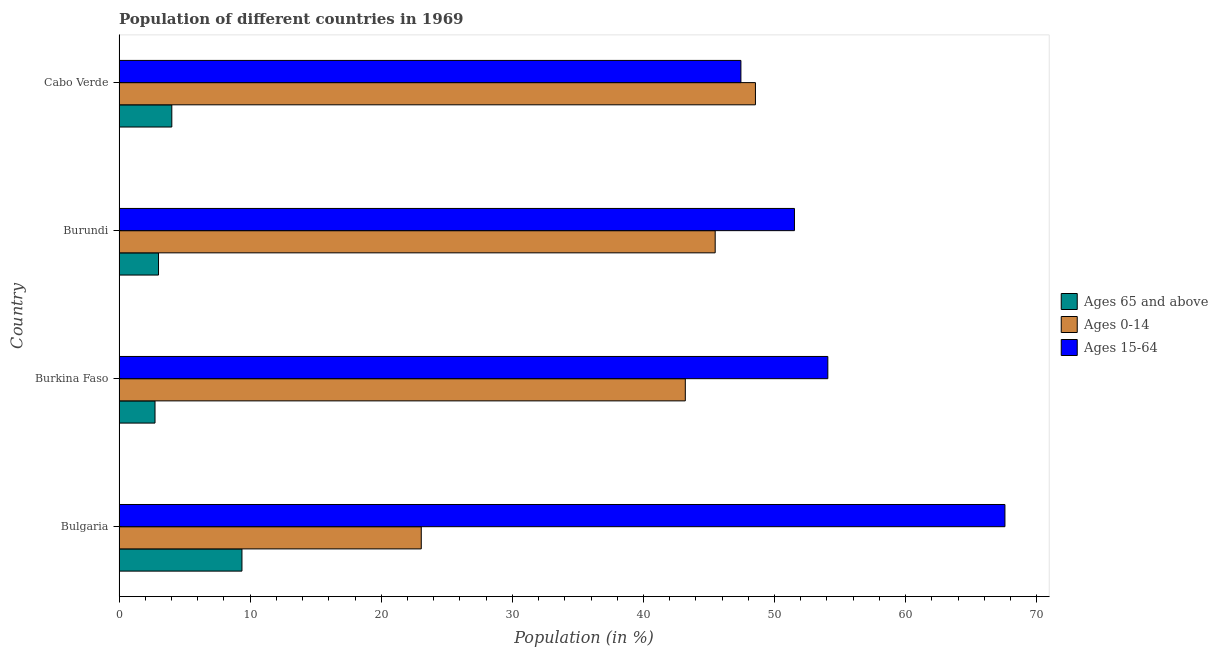How many groups of bars are there?
Give a very brief answer. 4. Are the number of bars per tick equal to the number of legend labels?
Your response must be concise. Yes. Are the number of bars on each tick of the Y-axis equal?
Provide a succinct answer. Yes. How many bars are there on the 3rd tick from the top?
Ensure brevity in your answer.  3. What is the label of the 1st group of bars from the top?
Offer a terse response. Cabo Verde. What is the percentage of population within the age-group of 65 and above in Bulgaria?
Your response must be concise. 9.37. Across all countries, what is the maximum percentage of population within the age-group 15-64?
Your answer should be compact. 67.57. Across all countries, what is the minimum percentage of population within the age-group 15-64?
Your response must be concise. 47.43. In which country was the percentage of population within the age-group 15-64 maximum?
Make the answer very short. Bulgaria. In which country was the percentage of population within the age-group 15-64 minimum?
Offer a terse response. Cabo Verde. What is the total percentage of population within the age-group 15-64 in the graph?
Give a very brief answer. 220.59. What is the difference between the percentage of population within the age-group 0-14 in Burkina Faso and that in Cabo Verde?
Offer a terse response. -5.35. What is the difference between the percentage of population within the age-group of 65 and above in Burundi and the percentage of population within the age-group 0-14 in Burkina Faso?
Ensure brevity in your answer.  -40.18. What is the average percentage of population within the age-group 0-14 per country?
Provide a succinct answer. 40.06. What is the difference between the percentage of population within the age-group of 65 and above and percentage of population within the age-group 0-14 in Burundi?
Your answer should be very brief. -42.46. In how many countries, is the percentage of population within the age-group 0-14 greater than 26 %?
Offer a terse response. 3. What is the difference between the highest and the second highest percentage of population within the age-group of 65 and above?
Make the answer very short. 5.35. What is the difference between the highest and the lowest percentage of population within the age-group 15-64?
Make the answer very short. 20.14. In how many countries, is the percentage of population within the age-group 0-14 greater than the average percentage of population within the age-group 0-14 taken over all countries?
Provide a short and direct response. 3. Is the sum of the percentage of population within the age-group 0-14 in Bulgaria and Burundi greater than the maximum percentage of population within the age-group of 65 and above across all countries?
Provide a short and direct response. Yes. What does the 1st bar from the top in Bulgaria represents?
Keep it short and to the point. Ages 15-64. What does the 2nd bar from the bottom in Burundi represents?
Your response must be concise. Ages 0-14. Is it the case that in every country, the sum of the percentage of population within the age-group of 65 and above and percentage of population within the age-group 0-14 is greater than the percentage of population within the age-group 15-64?
Give a very brief answer. No. How many bars are there?
Keep it short and to the point. 12. Are all the bars in the graph horizontal?
Your response must be concise. Yes. How many countries are there in the graph?
Your response must be concise. 4. Where does the legend appear in the graph?
Your response must be concise. Center right. How many legend labels are there?
Ensure brevity in your answer.  3. What is the title of the graph?
Your response must be concise. Population of different countries in 1969. What is the Population (in %) of Ages 65 and above in Bulgaria?
Your answer should be compact. 9.37. What is the Population (in %) of Ages 0-14 in Bulgaria?
Make the answer very short. 23.05. What is the Population (in %) of Ages 15-64 in Bulgaria?
Offer a terse response. 67.57. What is the Population (in %) in Ages 65 and above in Burkina Faso?
Give a very brief answer. 2.74. What is the Population (in %) of Ages 0-14 in Burkina Faso?
Provide a succinct answer. 43.19. What is the Population (in %) in Ages 15-64 in Burkina Faso?
Offer a terse response. 54.06. What is the Population (in %) of Ages 65 and above in Burundi?
Your answer should be very brief. 3.01. What is the Population (in %) of Ages 0-14 in Burundi?
Your answer should be very brief. 45.47. What is the Population (in %) of Ages 15-64 in Burundi?
Ensure brevity in your answer.  51.52. What is the Population (in %) in Ages 65 and above in Cabo Verde?
Ensure brevity in your answer.  4.02. What is the Population (in %) in Ages 0-14 in Cabo Verde?
Ensure brevity in your answer.  48.54. What is the Population (in %) in Ages 15-64 in Cabo Verde?
Make the answer very short. 47.43. Across all countries, what is the maximum Population (in %) of Ages 65 and above?
Your answer should be very brief. 9.37. Across all countries, what is the maximum Population (in %) of Ages 0-14?
Offer a terse response. 48.54. Across all countries, what is the maximum Population (in %) in Ages 15-64?
Provide a succinct answer. 67.57. Across all countries, what is the minimum Population (in %) in Ages 65 and above?
Offer a terse response. 2.74. Across all countries, what is the minimum Population (in %) of Ages 0-14?
Provide a succinct answer. 23.05. Across all countries, what is the minimum Population (in %) of Ages 15-64?
Give a very brief answer. 47.43. What is the total Population (in %) of Ages 65 and above in the graph?
Your answer should be very brief. 19.15. What is the total Population (in %) of Ages 0-14 in the graph?
Make the answer very short. 160.26. What is the total Population (in %) in Ages 15-64 in the graph?
Give a very brief answer. 220.59. What is the difference between the Population (in %) of Ages 65 and above in Bulgaria and that in Burkina Faso?
Provide a succinct answer. 6.63. What is the difference between the Population (in %) in Ages 0-14 in Bulgaria and that in Burkina Faso?
Your answer should be very brief. -20.14. What is the difference between the Population (in %) in Ages 15-64 in Bulgaria and that in Burkina Faso?
Offer a very short reply. 13.51. What is the difference between the Population (in %) in Ages 65 and above in Bulgaria and that in Burundi?
Offer a very short reply. 6.36. What is the difference between the Population (in %) of Ages 0-14 in Bulgaria and that in Burundi?
Your answer should be compact. -22.42. What is the difference between the Population (in %) in Ages 15-64 in Bulgaria and that in Burundi?
Keep it short and to the point. 16.06. What is the difference between the Population (in %) in Ages 65 and above in Bulgaria and that in Cabo Verde?
Your answer should be compact. 5.35. What is the difference between the Population (in %) of Ages 0-14 in Bulgaria and that in Cabo Verde?
Keep it short and to the point. -25.49. What is the difference between the Population (in %) of Ages 15-64 in Bulgaria and that in Cabo Verde?
Offer a terse response. 20.14. What is the difference between the Population (in %) in Ages 65 and above in Burkina Faso and that in Burundi?
Your answer should be compact. -0.27. What is the difference between the Population (in %) of Ages 0-14 in Burkina Faso and that in Burundi?
Give a very brief answer. -2.28. What is the difference between the Population (in %) in Ages 15-64 in Burkina Faso and that in Burundi?
Provide a succinct answer. 2.55. What is the difference between the Population (in %) in Ages 65 and above in Burkina Faso and that in Cabo Verde?
Give a very brief answer. -1.28. What is the difference between the Population (in %) in Ages 0-14 in Burkina Faso and that in Cabo Verde?
Offer a very short reply. -5.35. What is the difference between the Population (in %) of Ages 15-64 in Burkina Faso and that in Cabo Verde?
Give a very brief answer. 6.63. What is the difference between the Population (in %) of Ages 65 and above in Burundi and that in Cabo Verde?
Your answer should be compact. -1.01. What is the difference between the Population (in %) in Ages 0-14 in Burundi and that in Cabo Verde?
Offer a very short reply. -3.07. What is the difference between the Population (in %) of Ages 15-64 in Burundi and that in Cabo Verde?
Give a very brief answer. 4.08. What is the difference between the Population (in %) of Ages 65 and above in Bulgaria and the Population (in %) of Ages 0-14 in Burkina Faso?
Your answer should be compact. -33.82. What is the difference between the Population (in %) of Ages 65 and above in Bulgaria and the Population (in %) of Ages 15-64 in Burkina Faso?
Provide a short and direct response. -44.69. What is the difference between the Population (in %) of Ages 0-14 in Bulgaria and the Population (in %) of Ages 15-64 in Burkina Faso?
Offer a very short reply. -31.01. What is the difference between the Population (in %) in Ages 65 and above in Bulgaria and the Population (in %) in Ages 0-14 in Burundi?
Offer a very short reply. -36.1. What is the difference between the Population (in %) in Ages 65 and above in Bulgaria and the Population (in %) in Ages 15-64 in Burundi?
Ensure brevity in your answer.  -42.14. What is the difference between the Population (in %) of Ages 0-14 in Bulgaria and the Population (in %) of Ages 15-64 in Burundi?
Provide a succinct answer. -28.47. What is the difference between the Population (in %) of Ages 65 and above in Bulgaria and the Population (in %) of Ages 0-14 in Cabo Verde?
Your answer should be compact. -39.17. What is the difference between the Population (in %) in Ages 65 and above in Bulgaria and the Population (in %) in Ages 15-64 in Cabo Verde?
Provide a short and direct response. -38.06. What is the difference between the Population (in %) of Ages 0-14 in Bulgaria and the Population (in %) of Ages 15-64 in Cabo Verde?
Provide a succinct answer. -24.38. What is the difference between the Population (in %) in Ages 65 and above in Burkina Faso and the Population (in %) in Ages 0-14 in Burundi?
Keep it short and to the point. -42.73. What is the difference between the Population (in %) of Ages 65 and above in Burkina Faso and the Population (in %) of Ages 15-64 in Burundi?
Give a very brief answer. -48.77. What is the difference between the Population (in %) in Ages 0-14 in Burkina Faso and the Population (in %) in Ages 15-64 in Burundi?
Your response must be concise. -8.32. What is the difference between the Population (in %) of Ages 65 and above in Burkina Faso and the Population (in %) of Ages 0-14 in Cabo Verde?
Give a very brief answer. -45.8. What is the difference between the Population (in %) of Ages 65 and above in Burkina Faso and the Population (in %) of Ages 15-64 in Cabo Verde?
Your answer should be very brief. -44.69. What is the difference between the Population (in %) of Ages 0-14 in Burkina Faso and the Population (in %) of Ages 15-64 in Cabo Verde?
Provide a short and direct response. -4.24. What is the difference between the Population (in %) in Ages 65 and above in Burundi and the Population (in %) in Ages 0-14 in Cabo Verde?
Keep it short and to the point. -45.53. What is the difference between the Population (in %) of Ages 65 and above in Burundi and the Population (in %) of Ages 15-64 in Cabo Verde?
Make the answer very short. -44.42. What is the difference between the Population (in %) in Ages 0-14 in Burundi and the Population (in %) in Ages 15-64 in Cabo Verde?
Provide a short and direct response. -1.96. What is the average Population (in %) of Ages 65 and above per country?
Keep it short and to the point. 4.79. What is the average Population (in %) in Ages 0-14 per country?
Your answer should be compact. 40.06. What is the average Population (in %) in Ages 15-64 per country?
Make the answer very short. 55.15. What is the difference between the Population (in %) of Ages 65 and above and Population (in %) of Ages 0-14 in Bulgaria?
Your answer should be very brief. -13.68. What is the difference between the Population (in %) of Ages 65 and above and Population (in %) of Ages 15-64 in Bulgaria?
Keep it short and to the point. -58.2. What is the difference between the Population (in %) in Ages 0-14 and Population (in %) in Ages 15-64 in Bulgaria?
Your answer should be very brief. -44.52. What is the difference between the Population (in %) in Ages 65 and above and Population (in %) in Ages 0-14 in Burkina Faso?
Keep it short and to the point. -40.45. What is the difference between the Population (in %) of Ages 65 and above and Population (in %) of Ages 15-64 in Burkina Faso?
Provide a short and direct response. -51.32. What is the difference between the Population (in %) of Ages 0-14 and Population (in %) of Ages 15-64 in Burkina Faso?
Keep it short and to the point. -10.87. What is the difference between the Population (in %) of Ages 65 and above and Population (in %) of Ages 0-14 in Burundi?
Your response must be concise. -42.46. What is the difference between the Population (in %) of Ages 65 and above and Population (in %) of Ages 15-64 in Burundi?
Give a very brief answer. -48.51. What is the difference between the Population (in %) in Ages 0-14 and Population (in %) in Ages 15-64 in Burundi?
Offer a very short reply. -6.05. What is the difference between the Population (in %) in Ages 65 and above and Population (in %) in Ages 0-14 in Cabo Verde?
Ensure brevity in your answer.  -44.52. What is the difference between the Population (in %) of Ages 65 and above and Population (in %) of Ages 15-64 in Cabo Verde?
Provide a succinct answer. -43.41. What is the difference between the Population (in %) in Ages 0-14 and Population (in %) in Ages 15-64 in Cabo Verde?
Keep it short and to the point. 1.11. What is the ratio of the Population (in %) of Ages 65 and above in Bulgaria to that in Burkina Faso?
Ensure brevity in your answer.  3.42. What is the ratio of the Population (in %) of Ages 0-14 in Bulgaria to that in Burkina Faso?
Your response must be concise. 0.53. What is the ratio of the Population (in %) of Ages 15-64 in Bulgaria to that in Burkina Faso?
Make the answer very short. 1.25. What is the ratio of the Population (in %) of Ages 65 and above in Bulgaria to that in Burundi?
Give a very brief answer. 3.11. What is the ratio of the Population (in %) in Ages 0-14 in Bulgaria to that in Burundi?
Ensure brevity in your answer.  0.51. What is the ratio of the Population (in %) in Ages 15-64 in Bulgaria to that in Burundi?
Ensure brevity in your answer.  1.31. What is the ratio of the Population (in %) of Ages 65 and above in Bulgaria to that in Cabo Verde?
Your answer should be very brief. 2.33. What is the ratio of the Population (in %) of Ages 0-14 in Bulgaria to that in Cabo Verde?
Keep it short and to the point. 0.47. What is the ratio of the Population (in %) in Ages 15-64 in Bulgaria to that in Cabo Verde?
Offer a terse response. 1.42. What is the ratio of the Population (in %) in Ages 65 and above in Burkina Faso to that in Burundi?
Ensure brevity in your answer.  0.91. What is the ratio of the Population (in %) of Ages 0-14 in Burkina Faso to that in Burundi?
Ensure brevity in your answer.  0.95. What is the ratio of the Population (in %) of Ages 15-64 in Burkina Faso to that in Burundi?
Your answer should be very brief. 1.05. What is the ratio of the Population (in %) in Ages 65 and above in Burkina Faso to that in Cabo Verde?
Provide a short and direct response. 0.68. What is the ratio of the Population (in %) of Ages 0-14 in Burkina Faso to that in Cabo Verde?
Offer a very short reply. 0.89. What is the ratio of the Population (in %) in Ages 15-64 in Burkina Faso to that in Cabo Verde?
Keep it short and to the point. 1.14. What is the ratio of the Population (in %) of Ages 65 and above in Burundi to that in Cabo Verde?
Make the answer very short. 0.75. What is the ratio of the Population (in %) of Ages 0-14 in Burundi to that in Cabo Verde?
Provide a succinct answer. 0.94. What is the ratio of the Population (in %) in Ages 15-64 in Burundi to that in Cabo Verde?
Provide a succinct answer. 1.09. What is the difference between the highest and the second highest Population (in %) of Ages 65 and above?
Your response must be concise. 5.35. What is the difference between the highest and the second highest Population (in %) of Ages 0-14?
Ensure brevity in your answer.  3.07. What is the difference between the highest and the second highest Population (in %) of Ages 15-64?
Provide a short and direct response. 13.51. What is the difference between the highest and the lowest Population (in %) of Ages 65 and above?
Provide a short and direct response. 6.63. What is the difference between the highest and the lowest Population (in %) of Ages 0-14?
Your answer should be very brief. 25.49. What is the difference between the highest and the lowest Population (in %) of Ages 15-64?
Keep it short and to the point. 20.14. 